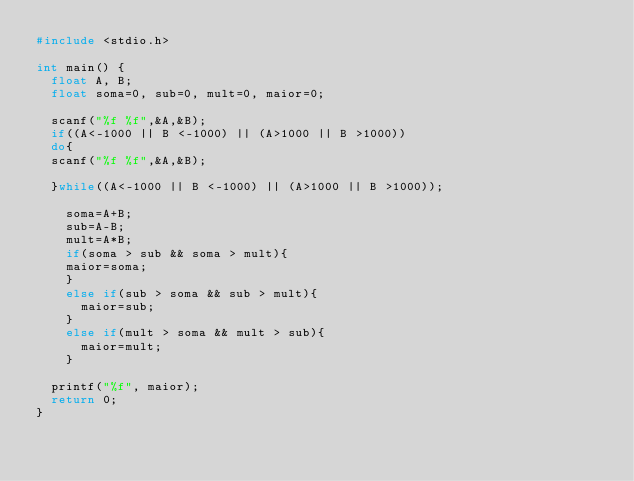Convert code to text. <code><loc_0><loc_0><loc_500><loc_500><_C_>#include <stdio.h>

int main() {
	float A, B;
	float soma=0, sub=0, mult=0, maior=0;
	
	scanf("%f %f",&A,&B);
	if((A<-1000 || B <-1000) || (A>1000 || B >1000))
	do{
	scanf("%f %f",&A,&B);
	
	}while((A<-1000 || B <-1000) || (A>1000 || B >1000));
	
		soma=A+B;
		sub=A-B;
		mult=A*B;
		if(soma > sub && soma > mult){
		maior=soma;
		}
		else if(sub > soma && sub > mult){
			maior=sub;
		}
		else if(mult > soma && mult > sub){
			maior=mult;
		}
	
	printf("%f", maior);
	return 0;
}
</code> 